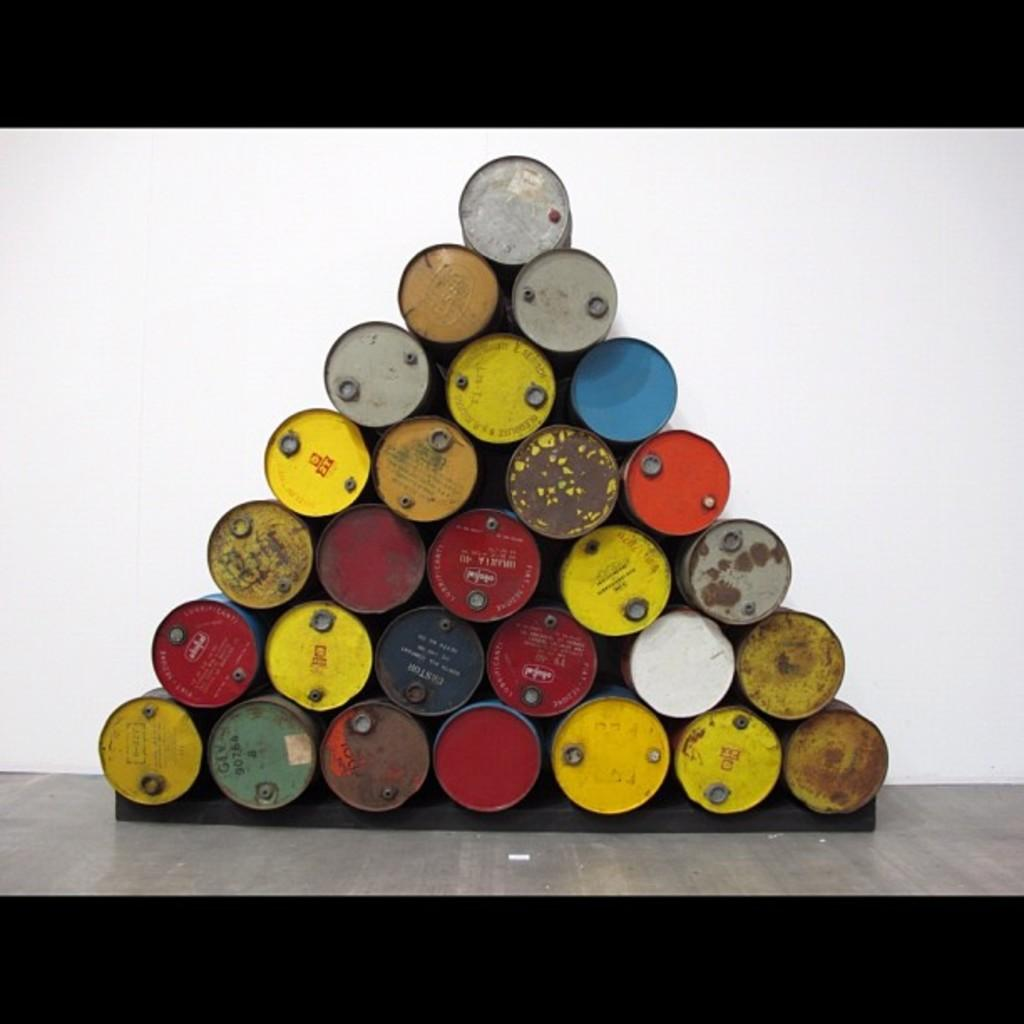What objects are in the image? There are oil drums in the image. How are the oil drums arranged? The oil drums are arranged in a triangle shape. What can be seen behind the oil drums? There is a white wall behind the oil drums. What type of horn can be heard in the image? There is no horn present in the image, so it is not possible to determine what type of horn might be heard. 